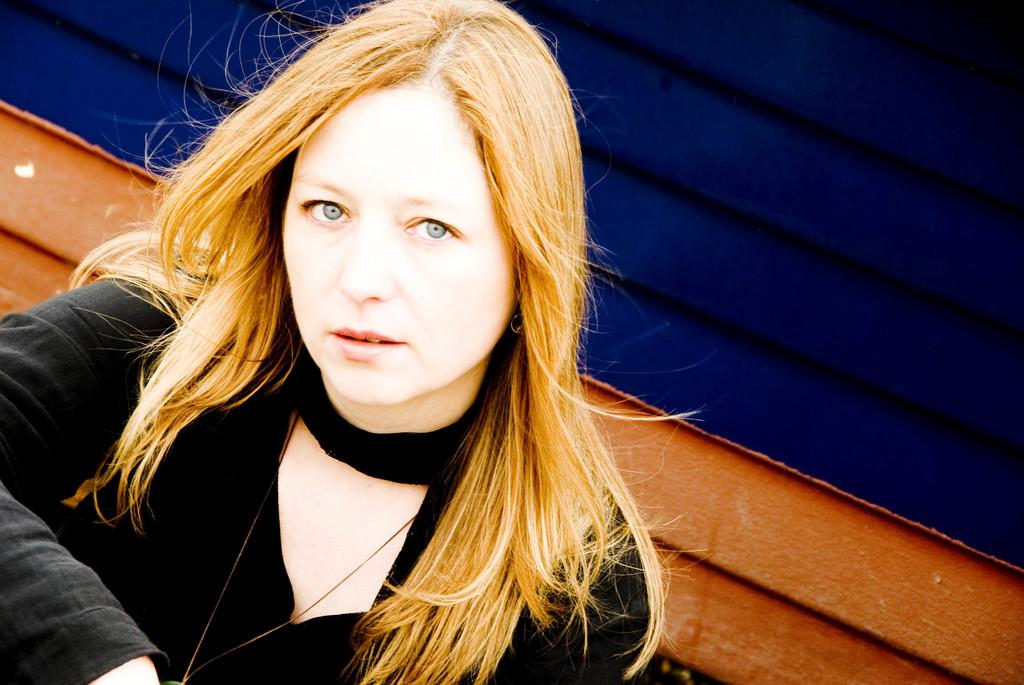Who is the main subject in the image? There is a girl in the image. What is the girl wearing? The girl is wearing a black dress. What can be seen behind the girl? There is a wall behind the girl. What type of creature is sitting on the clover in the image? There is no clover or creature present in the image; it features a girl wearing a black dress with a wall behind her. 